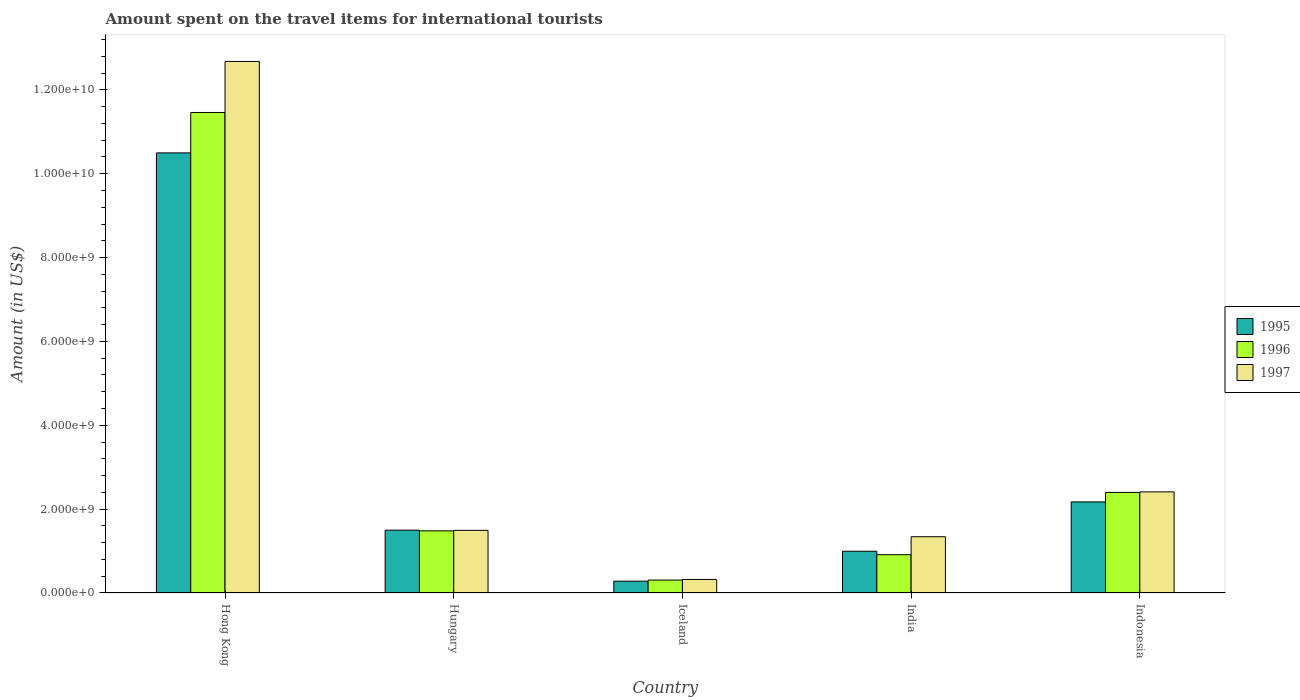How many different coloured bars are there?
Your answer should be compact. 3. How many groups of bars are there?
Provide a succinct answer. 5. Are the number of bars per tick equal to the number of legend labels?
Your answer should be compact. Yes. Are the number of bars on each tick of the X-axis equal?
Give a very brief answer. Yes. What is the amount spent on the travel items for international tourists in 1996 in Indonesia?
Offer a terse response. 2.40e+09. Across all countries, what is the maximum amount spent on the travel items for international tourists in 1996?
Provide a short and direct response. 1.15e+1. Across all countries, what is the minimum amount spent on the travel items for international tourists in 1996?
Keep it short and to the point. 3.08e+08. In which country was the amount spent on the travel items for international tourists in 1996 maximum?
Offer a very short reply. Hong Kong. In which country was the amount spent on the travel items for international tourists in 1995 minimum?
Give a very brief answer. Iceland. What is the total amount spent on the travel items for international tourists in 1997 in the graph?
Give a very brief answer. 1.82e+1. What is the difference between the amount spent on the travel items for international tourists in 1997 in Hong Kong and that in Hungary?
Provide a succinct answer. 1.12e+1. What is the difference between the amount spent on the travel items for international tourists in 1997 in India and the amount spent on the travel items for international tourists in 1995 in Hungary?
Make the answer very short. -1.56e+08. What is the average amount spent on the travel items for international tourists in 1997 per country?
Your answer should be very brief. 3.65e+09. What is the difference between the amount spent on the travel items for international tourists of/in 1995 and amount spent on the travel items for international tourists of/in 1996 in Hungary?
Provide a short and direct response. 1.60e+07. In how many countries, is the amount spent on the travel items for international tourists in 1996 greater than 4800000000 US$?
Provide a succinct answer. 1. What is the ratio of the amount spent on the travel items for international tourists in 1995 in Iceland to that in India?
Your answer should be compact. 0.28. Is the difference between the amount spent on the travel items for international tourists in 1995 in Hong Kong and Indonesia greater than the difference between the amount spent on the travel items for international tourists in 1996 in Hong Kong and Indonesia?
Offer a terse response. No. What is the difference between the highest and the second highest amount spent on the travel items for international tourists in 1997?
Offer a very short reply. 1.12e+1. What is the difference between the highest and the lowest amount spent on the travel items for international tourists in 1996?
Make the answer very short. 1.12e+1. In how many countries, is the amount spent on the travel items for international tourists in 1996 greater than the average amount spent on the travel items for international tourists in 1996 taken over all countries?
Keep it short and to the point. 1. Are all the bars in the graph horizontal?
Provide a short and direct response. No. What is the difference between two consecutive major ticks on the Y-axis?
Provide a short and direct response. 2.00e+09. Are the values on the major ticks of Y-axis written in scientific E-notation?
Give a very brief answer. Yes. How many legend labels are there?
Keep it short and to the point. 3. How are the legend labels stacked?
Your answer should be very brief. Vertical. What is the title of the graph?
Offer a very short reply. Amount spent on the travel items for international tourists. Does "1993" appear as one of the legend labels in the graph?
Your answer should be very brief. No. What is the label or title of the Y-axis?
Make the answer very short. Amount (in US$). What is the Amount (in US$) of 1995 in Hong Kong?
Offer a terse response. 1.05e+1. What is the Amount (in US$) in 1996 in Hong Kong?
Provide a succinct answer. 1.15e+1. What is the Amount (in US$) in 1997 in Hong Kong?
Offer a terse response. 1.27e+1. What is the Amount (in US$) in 1995 in Hungary?
Your answer should be compact. 1.50e+09. What is the Amount (in US$) in 1996 in Hungary?
Ensure brevity in your answer.  1.48e+09. What is the Amount (in US$) in 1997 in Hungary?
Offer a very short reply. 1.49e+09. What is the Amount (in US$) of 1995 in Iceland?
Your response must be concise. 2.82e+08. What is the Amount (in US$) of 1996 in Iceland?
Your answer should be very brief. 3.08e+08. What is the Amount (in US$) of 1997 in Iceland?
Offer a terse response. 3.23e+08. What is the Amount (in US$) of 1995 in India?
Ensure brevity in your answer.  9.96e+08. What is the Amount (in US$) in 1996 in India?
Your answer should be compact. 9.13e+08. What is the Amount (in US$) in 1997 in India?
Provide a short and direct response. 1.34e+09. What is the Amount (in US$) in 1995 in Indonesia?
Keep it short and to the point. 2.17e+09. What is the Amount (in US$) in 1996 in Indonesia?
Make the answer very short. 2.40e+09. What is the Amount (in US$) of 1997 in Indonesia?
Your response must be concise. 2.41e+09. Across all countries, what is the maximum Amount (in US$) in 1995?
Provide a succinct answer. 1.05e+1. Across all countries, what is the maximum Amount (in US$) of 1996?
Make the answer very short. 1.15e+1. Across all countries, what is the maximum Amount (in US$) of 1997?
Ensure brevity in your answer.  1.27e+1. Across all countries, what is the minimum Amount (in US$) in 1995?
Offer a terse response. 2.82e+08. Across all countries, what is the minimum Amount (in US$) of 1996?
Your answer should be very brief. 3.08e+08. Across all countries, what is the minimum Amount (in US$) in 1997?
Your answer should be compact. 3.23e+08. What is the total Amount (in US$) of 1995 in the graph?
Give a very brief answer. 1.54e+1. What is the total Amount (in US$) in 1996 in the graph?
Your response must be concise. 1.66e+1. What is the total Amount (in US$) of 1997 in the graph?
Ensure brevity in your answer.  1.82e+1. What is the difference between the Amount (in US$) of 1995 in Hong Kong and that in Hungary?
Your response must be concise. 9.00e+09. What is the difference between the Amount (in US$) of 1996 in Hong Kong and that in Hungary?
Offer a terse response. 9.98e+09. What is the difference between the Amount (in US$) of 1997 in Hong Kong and that in Hungary?
Make the answer very short. 1.12e+1. What is the difference between the Amount (in US$) in 1995 in Hong Kong and that in Iceland?
Your answer should be very brief. 1.02e+1. What is the difference between the Amount (in US$) in 1996 in Hong Kong and that in Iceland?
Keep it short and to the point. 1.12e+1. What is the difference between the Amount (in US$) of 1997 in Hong Kong and that in Iceland?
Make the answer very short. 1.24e+1. What is the difference between the Amount (in US$) of 1995 in Hong Kong and that in India?
Your answer should be compact. 9.50e+09. What is the difference between the Amount (in US$) of 1996 in Hong Kong and that in India?
Your answer should be compact. 1.05e+1. What is the difference between the Amount (in US$) of 1997 in Hong Kong and that in India?
Offer a very short reply. 1.13e+1. What is the difference between the Amount (in US$) in 1995 in Hong Kong and that in Indonesia?
Keep it short and to the point. 8.32e+09. What is the difference between the Amount (in US$) in 1996 in Hong Kong and that in Indonesia?
Your answer should be compact. 9.06e+09. What is the difference between the Amount (in US$) in 1997 in Hong Kong and that in Indonesia?
Your answer should be compact. 1.03e+1. What is the difference between the Amount (in US$) of 1995 in Hungary and that in Iceland?
Keep it short and to the point. 1.22e+09. What is the difference between the Amount (in US$) in 1996 in Hungary and that in Iceland?
Your answer should be compact. 1.17e+09. What is the difference between the Amount (in US$) of 1997 in Hungary and that in Iceland?
Your answer should be very brief. 1.17e+09. What is the difference between the Amount (in US$) of 1995 in Hungary and that in India?
Ensure brevity in your answer.  5.02e+08. What is the difference between the Amount (in US$) of 1996 in Hungary and that in India?
Your answer should be very brief. 5.69e+08. What is the difference between the Amount (in US$) in 1997 in Hungary and that in India?
Your response must be concise. 1.52e+08. What is the difference between the Amount (in US$) in 1995 in Hungary and that in Indonesia?
Provide a short and direct response. -6.74e+08. What is the difference between the Amount (in US$) of 1996 in Hungary and that in Indonesia?
Keep it short and to the point. -9.17e+08. What is the difference between the Amount (in US$) of 1997 in Hungary and that in Indonesia?
Provide a short and direct response. -9.17e+08. What is the difference between the Amount (in US$) of 1995 in Iceland and that in India?
Your answer should be compact. -7.14e+08. What is the difference between the Amount (in US$) in 1996 in Iceland and that in India?
Offer a terse response. -6.05e+08. What is the difference between the Amount (in US$) of 1997 in Iceland and that in India?
Your answer should be compact. -1.02e+09. What is the difference between the Amount (in US$) of 1995 in Iceland and that in Indonesia?
Your answer should be compact. -1.89e+09. What is the difference between the Amount (in US$) of 1996 in Iceland and that in Indonesia?
Keep it short and to the point. -2.09e+09. What is the difference between the Amount (in US$) of 1997 in Iceland and that in Indonesia?
Make the answer very short. -2.09e+09. What is the difference between the Amount (in US$) of 1995 in India and that in Indonesia?
Provide a short and direct response. -1.18e+09. What is the difference between the Amount (in US$) in 1996 in India and that in Indonesia?
Provide a short and direct response. -1.49e+09. What is the difference between the Amount (in US$) of 1997 in India and that in Indonesia?
Offer a very short reply. -1.07e+09. What is the difference between the Amount (in US$) in 1995 in Hong Kong and the Amount (in US$) in 1996 in Hungary?
Provide a succinct answer. 9.02e+09. What is the difference between the Amount (in US$) in 1995 in Hong Kong and the Amount (in US$) in 1997 in Hungary?
Provide a short and direct response. 9.00e+09. What is the difference between the Amount (in US$) in 1996 in Hong Kong and the Amount (in US$) in 1997 in Hungary?
Offer a very short reply. 9.97e+09. What is the difference between the Amount (in US$) of 1995 in Hong Kong and the Amount (in US$) of 1996 in Iceland?
Your answer should be very brief. 1.02e+1. What is the difference between the Amount (in US$) in 1995 in Hong Kong and the Amount (in US$) in 1997 in Iceland?
Keep it short and to the point. 1.02e+1. What is the difference between the Amount (in US$) of 1996 in Hong Kong and the Amount (in US$) of 1997 in Iceland?
Keep it short and to the point. 1.11e+1. What is the difference between the Amount (in US$) of 1995 in Hong Kong and the Amount (in US$) of 1996 in India?
Provide a short and direct response. 9.58e+09. What is the difference between the Amount (in US$) in 1995 in Hong Kong and the Amount (in US$) in 1997 in India?
Make the answer very short. 9.16e+09. What is the difference between the Amount (in US$) in 1996 in Hong Kong and the Amount (in US$) in 1997 in India?
Keep it short and to the point. 1.01e+1. What is the difference between the Amount (in US$) in 1995 in Hong Kong and the Amount (in US$) in 1996 in Indonesia?
Make the answer very short. 8.10e+09. What is the difference between the Amount (in US$) of 1995 in Hong Kong and the Amount (in US$) of 1997 in Indonesia?
Your answer should be compact. 8.09e+09. What is the difference between the Amount (in US$) of 1996 in Hong Kong and the Amount (in US$) of 1997 in Indonesia?
Keep it short and to the point. 9.05e+09. What is the difference between the Amount (in US$) of 1995 in Hungary and the Amount (in US$) of 1996 in Iceland?
Provide a short and direct response. 1.19e+09. What is the difference between the Amount (in US$) of 1995 in Hungary and the Amount (in US$) of 1997 in Iceland?
Your answer should be compact. 1.18e+09. What is the difference between the Amount (in US$) of 1996 in Hungary and the Amount (in US$) of 1997 in Iceland?
Give a very brief answer. 1.16e+09. What is the difference between the Amount (in US$) in 1995 in Hungary and the Amount (in US$) in 1996 in India?
Make the answer very short. 5.85e+08. What is the difference between the Amount (in US$) of 1995 in Hungary and the Amount (in US$) of 1997 in India?
Offer a very short reply. 1.56e+08. What is the difference between the Amount (in US$) of 1996 in Hungary and the Amount (in US$) of 1997 in India?
Make the answer very short. 1.40e+08. What is the difference between the Amount (in US$) of 1995 in Hungary and the Amount (in US$) of 1996 in Indonesia?
Offer a very short reply. -9.01e+08. What is the difference between the Amount (in US$) in 1995 in Hungary and the Amount (in US$) in 1997 in Indonesia?
Your answer should be very brief. -9.13e+08. What is the difference between the Amount (in US$) of 1996 in Hungary and the Amount (in US$) of 1997 in Indonesia?
Your answer should be compact. -9.29e+08. What is the difference between the Amount (in US$) in 1995 in Iceland and the Amount (in US$) in 1996 in India?
Provide a short and direct response. -6.31e+08. What is the difference between the Amount (in US$) in 1995 in Iceland and the Amount (in US$) in 1997 in India?
Your response must be concise. -1.06e+09. What is the difference between the Amount (in US$) of 1996 in Iceland and the Amount (in US$) of 1997 in India?
Keep it short and to the point. -1.03e+09. What is the difference between the Amount (in US$) of 1995 in Iceland and the Amount (in US$) of 1996 in Indonesia?
Make the answer very short. -2.12e+09. What is the difference between the Amount (in US$) of 1995 in Iceland and the Amount (in US$) of 1997 in Indonesia?
Give a very brief answer. -2.13e+09. What is the difference between the Amount (in US$) of 1996 in Iceland and the Amount (in US$) of 1997 in Indonesia?
Offer a very short reply. -2.10e+09. What is the difference between the Amount (in US$) of 1995 in India and the Amount (in US$) of 1996 in Indonesia?
Your response must be concise. -1.40e+09. What is the difference between the Amount (in US$) in 1995 in India and the Amount (in US$) in 1997 in Indonesia?
Your response must be concise. -1.42e+09. What is the difference between the Amount (in US$) in 1996 in India and the Amount (in US$) in 1997 in Indonesia?
Your response must be concise. -1.50e+09. What is the average Amount (in US$) of 1995 per country?
Offer a very short reply. 3.09e+09. What is the average Amount (in US$) in 1996 per country?
Your answer should be compact. 3.31e+09. What is the average Amount (in US$) of 1997 per country?
Ensure brevity in your answer.  3.65e+09. What is the difference between the Amount (in US$) of 1995 and Amount (in US$) of 1996 in Hong Kong?
Make the answer very short. -9.64e+08. What is the difference between the Amount (in US$) of 1995 and Amount (in US$) of 1997 in Hong Kong?
Offer a very short reply. -2.18e+09. What is the difference between the Amount (in US$) in 1996 and Amount (in US$) in 1997 in Hong Kong?
Ensure brevity in your answer.  -1.22e+09. What is the difference between the Amount (in US$) of 1995 and Amount (in US$) of 1996 in Hungary?
Your response must be concise. 1.60e+07. What is the difference between the Amount (in US$) in 1996 and Amount (in US$) in 1997 in Hungary?
Give a very brief answer. -1.20e+07. What is the difference between the Amount (in US$) in 1995 and Amount (in US$) in 1996 in Iceland?
Your response must be concise. -2.60e+07. What is the difference between the Amount (in US$) of 1995 and Amount (in US$) of 1997 in Iceland?
Your response must be concise. -4.10e+07. What is the difference between the Amount (in US$) in 1996 and Amount (in US$) in 1997 in Iceland?
Your answer should be compact. -1.50e+07. What is the difference between the Amount (in US$) in 1995 and Amount (in US$) in 1996 in India?
Provide a succinct answer. 8.30e+07. What is the difference between the Amount (in US$) of 1995 and Amount (in US$) of 1997 in India?
Provide a succinct answer. -3.46e+08. What is the difference between the Amount (in US$) in 1996 and Amount (in US$) in 1997 in India?
Give a very brief answer. -4.29e+08. What is the difference between the Amount (in US$) of 1995 and Amount (in US$) of 1996 in Indonesia?
Your answer should be compact. -2.27e+08. What is the difference between the Amount (in US$) in 1995 and Amount (in US$) in 1997 in Indonesia?
Give a very brief answer. -2.39e+08. What is the difference between the Amount (in US$) of 1996 and Amount (in US$) of 1997 in Indonesia?
Make the answer very short. -1.20e+07. What is the ratio of the Amount (in US$) in 1995 in Hong Kong to that in Hungary?
Your answer should be compact. 7.01. What is the ratio of the Amount (in US$) in 1996 in Hong Kong to that in Hungary?
Offer a very short reply. 7.73. What is the ratio of the Amount (in US$) in 1997 in Hong Kong to that in Hungary?
Provide a short and direct response. 8.49. What is the ratio of the Amount (in US$) in 1995 in Hong Kong to that in Iceland?
Provide a succinct answer. 37.22. What is the ratio of the Amount (in US$) in 1996 in Hong Kong to that in Iceland?
Your answer should be very brief. 37.21. What is the ratio of the Amount (in US$) in 1997 in Hong Kong to that in Iceland?
Offer a very short reply. 39.25. What is the ratio of the Amount (in US$) in 1995 in Hong Kong to that in India?
Make the answer very short. 10.54. What is the ratio of the Amount (in US$) of 1996 in Hong Kong to that in India?
Offer a very short reply. 12.55. What is the ratio of the Amount (in US$) in 1997 in Hong Kong to that in India?
Offer a very short reply. 9.45. What is the ratio of the Amount (in US$) of 1995 in Hong Kong to that in Indonesia?
Keep it short and to the point. 4.83. What is the ratio of the Amount (in US$) in 1996 in Hong Kong to that in Indonesia?
Offer a terse response. 4.78. What is the ratio of the Amount (in US$) in 1997 in Hong Kong to that in Indonesia?
Your answer should be compact. 5.26. What is the ratio of the Amount (in US$) in 1995 in Hungary to that in Iceland?
Your response must be concise. 5.31. What is the ratio of the Amount (in US$) in 1996 in Hungary to that in Iceland?
Provide a short and direct response. 4.81. What is the ratio of the Amount (in US$) of 1997 in Hungary to that in Iceland?
Your answer should be compact. 4.63. What is the ratio of the Amount (in US$) of 1995 in Hungary to that in India?
Make the answer very short. 1.5. What is the ratio of the Amount (in US$) of 1996 in Hungary to that in India?
Provide a succinct answer. 1.62. What is the ratio of the Amount (in US$) in 1997 in Hungary to that in India?
Make the answer very short. 1.11. What is the ratio of the Amount (in US$) of 1995 in Hungary to that in Indonesia?
Ensure brevity in your answer.  0.69. What is the ratio of the Amount (in US$) in 1996 in Hungary to that in Indonesia?
Your answer should be very brief. 0.62. What is the ratio of the Amount (in US$) of 1997 in Hungary to that in Indonesia?
Give a very brief answer. 0.62. What is the ratio of the Amount (in US$) in 1995 in Iceland to that in India?
Offer a terse response. 0.28. What is the ratio of the Amount (in US$) of 1996 in Iceland to that in India?
Provide a short and direct response. 0.34. What is the ratio of the Amount (in US$) in 1997 in Iceland to that in India?
Your answer should be very brief. 0.24. What is the ratio of the Amount (in US$) of 1995 in Iceland to that in Indonesia?
Provide a short and direct response. 0.13. What is the ratio of the Amount (in US$) in 1996 in Iceland to that in Indonesia?
Offer a very short reply. 0.13. What is the ratio of the Amount (in US$) of 1997 in Iceland to that in Indonesia?
Provide a short and direct response. 0.13. What is the ratio of the Amount (in US$) of 1995 in India to that in Indonesia?
Provide a succinct answer. 0.46. What is the ratio of the Amount (in US$) in 1996 in India to that in Indonesia?
Make the answer very short. 0.38. What is the ratio of the Amount (in US$) in 1997 in India to that in Indonesia?
Offer a terse response. 0.56. What is the difference between the highest and the second highest Amount (in US$) of 1995?
Provide a short and direct response. 8.32e+09. What is the difference between the highest and the second highest Amount (in US$) of 1996?
Your answer should be very brief. 9.06e+09. What is the difference between the highest and the second highest Amount (in US$) of 1997?
Keep it short and to the point. 1.03e+1. What is the difference between the highest and the lowest Amount (in US$) of 1995?
Your answer should be compact. 1.02e+1. What is the difference between the highest and the lowest Amount (in US$) of 1996?
Ensure brevity in your answer.  1.12e+1. What is the difference between the highest and the lowest Amount (in US$) in 1997?
Your answer should be compact. 1.24e+1. 